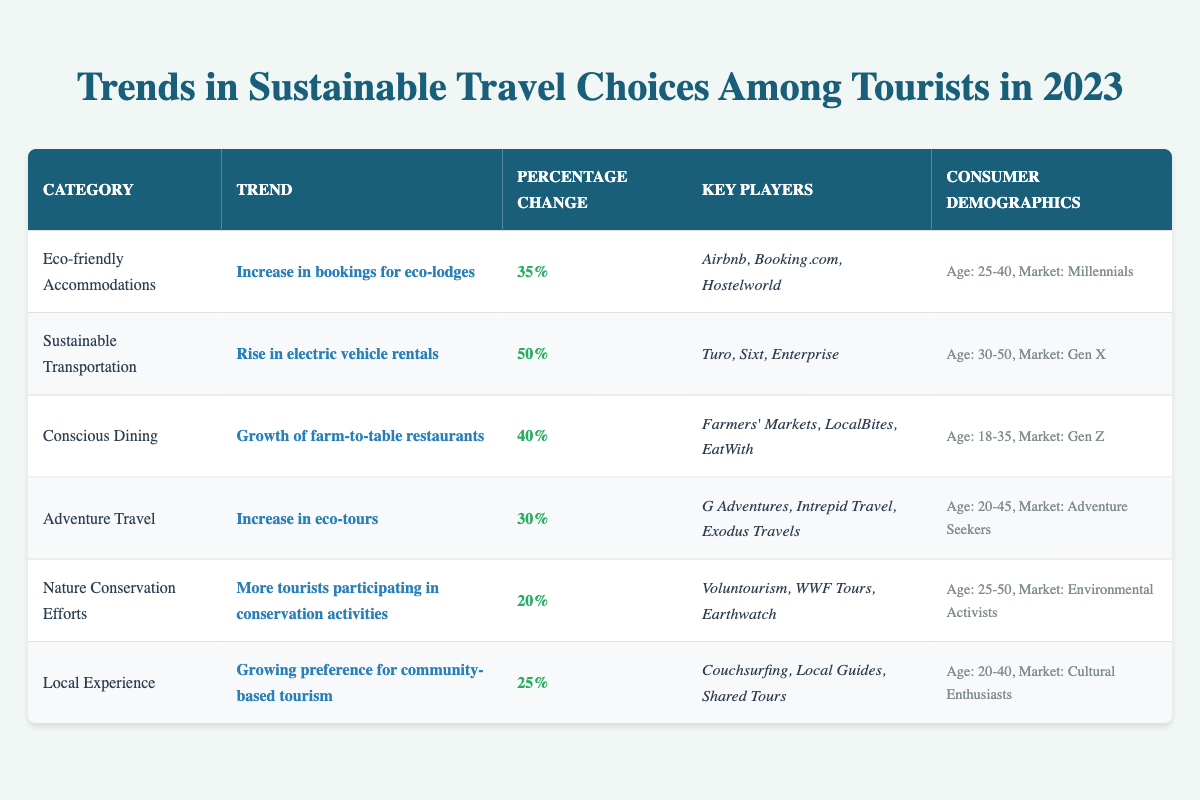What is the percentage change for eco-friendly accommodations? According to the table, the percentage change for eco-friendly accommodations is listed as 35%.
Answer: 35% Which category has the highest percentage change? The table lists various categories with their corresponding percentage changes. Sustainable Transportation shows the highest change at 50%.
Answer: Sustainable Transportation Are tourists aged 30-50 primarily engaging in eco-friendly accommodations? The table specifies that the primary market for eco-friendly accommodations is Millennials, aged 25-40, not the age group 30-50.
Answer: No How many key players are listed for Conscious Dining? The table mentions three key players under the Conscious Dining category: Farmers' Markets, LocalBites, and EatWith.
Answer: 3 What is the average percentage change across all categories? The percentages for each category are 35%, 50%, 40%, 30%, 20%, and 25%. Summing these gives 230%, and dividing by 6 (the number of categories) results in an average of approximately 38.33%.
Answer: Approximately 38.33% Which category's trend involves participation in conservation activities? The category that involves tourists participating in conservation activities is Nature Conservation Efforts, as indicated in the table.
Answer: Nature Conservation Efforts Is there a higher percentage change for local experience compared to adventure travel? The percentage change for Local Experience is 25%, while for Adventure Travel it is 30%. Since 30% is higher than 25%, the answer is no.
Answer: No What is the trend associated with the largest percentage increase? By comparing the percentage changes, the trend associated with the largest increase is Sustainable Transportation, with 50% growth, according to the information in the table.
Answer: Rise in electric vehicle rentals Which demographic group shows a preference for eco-tours? The Adventure Travel category indicates that the primary market for eco-tours includes Adventure Seekers, which generally encompasses those between age 20 to 45.
Answer: Adventure Seekers Calculate the total percentage change for all categories combined. The total percentage change is calculated by summing the individual percentage changes: 35% + 50% + 40% + 30% + 20% + 25% = 230%.
Answer: 230% 